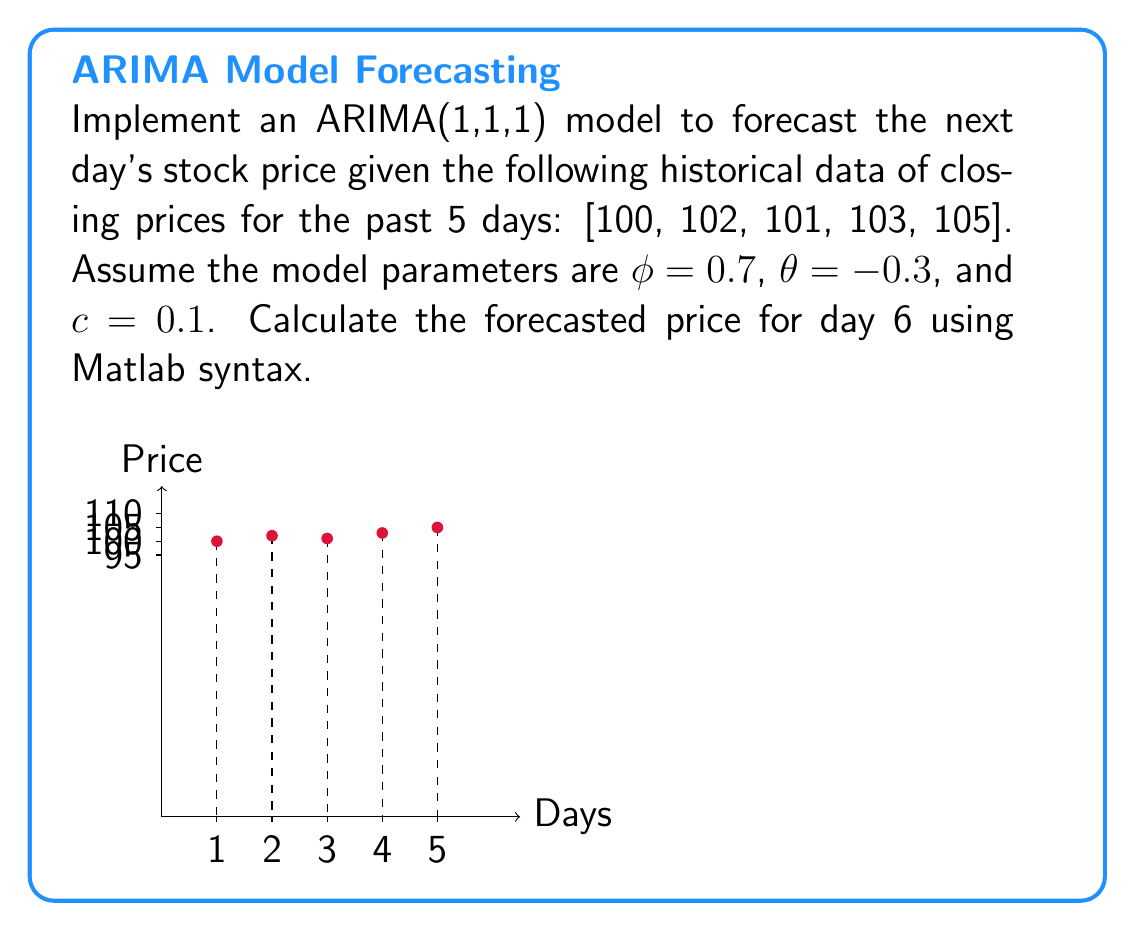Can you solve this math problem? To implement the ARIMA(1,1,1) model and forecast the next day's stock price, we'll follow these steps:

1) First, we need to difference the data once to make it stationary:
   $$y_t = (1-B)x_t = x_t - x_{t-1}$$
   where $B$ is the backshift operator.

   In Matlab, this can be done as:
   ```matlab
   y = diff([100, 102, 101, 103, 105]);
   ```
   This gives us: $y = [2, -1, 2, 2]$

2) Now, we apply the ARMA(1,1) model to the differenced data:
   $$y_t = c + \phi y_{t-1} + \epsilon_t + \theta \epsilon_{t-1}$$

3) To forecast $y_5$ (which corresponds to the difference for day 6), we use:
   $$\hat{y}_5 = c + \phi y_4 + \theta \epsilon_4$$

   Here, $y_4 = 2$ (the last value of our differenced series).

4) We need to estimate $\epsilon_4$. In practice, this would be calculated recursively, but for simplicity, we'll assume it's the difference between the observed and predicted value for $y_4$:
   $$\epsilon_4 \approx y_4 - (c + \phi y_3 + \theta \epsilon_3) \approx 2 - (0.1 + 0.7 * 2) = 0.5$$

5) Now we can calculate $\hat{y}_5$:
   $$\hat{y}_5 = 0.1 + 0.7 * 2 + (-0.3) * 0.5 = 1.45$$

6) To get the forecasted price for day 6, we need to "undifference" our result:
   $$\hat{x}_6 = x_5 + \hat{y}_5 = 105 + 1.45 = 106.45$$

In Matlab, the final forecast can be computed as:
```matlab
x = [100, 102, 101, 103, 105];
y = diff(x);
y_hat = 0.1 + 0.7*y(end) + (-0.3)*(y(end) - (0.1 + 0.7*y(end-1)));
x_forecast = x(end) + y_hat;
```
Answer: 106.45 